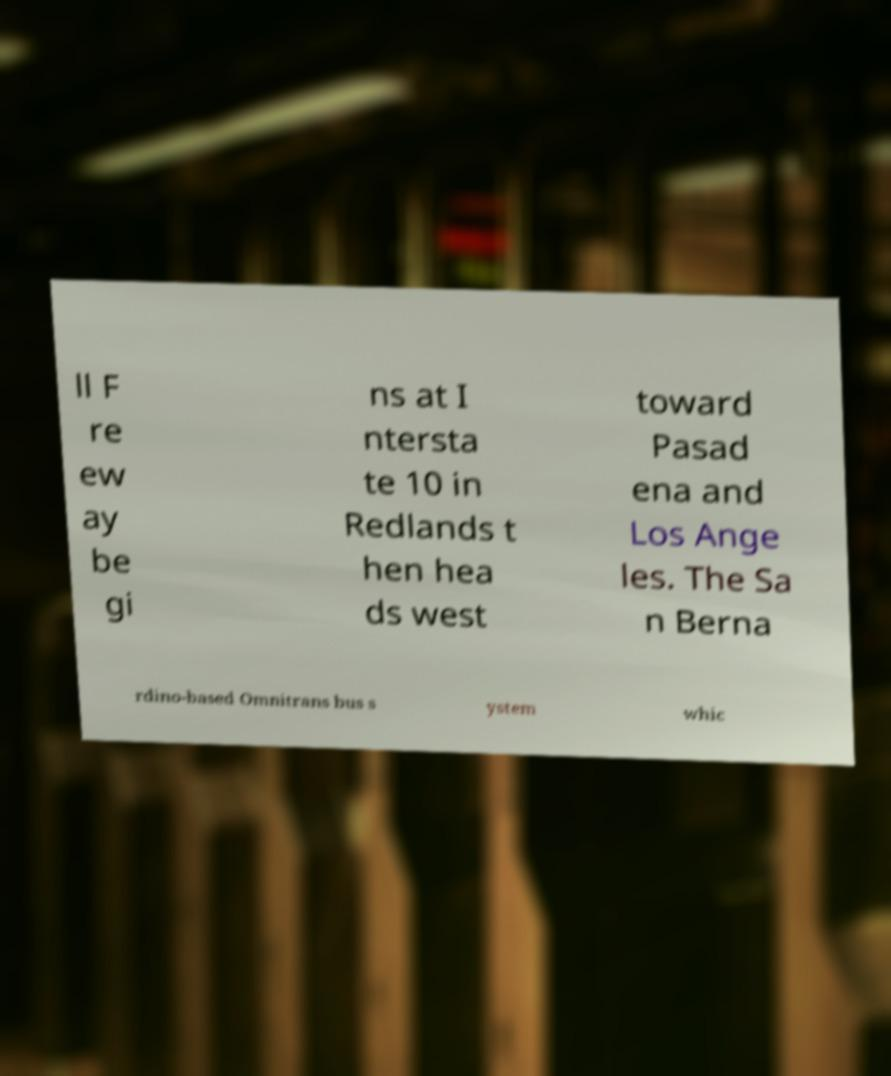Could you extract and type out the text from this image? ll F re ew ay be gi ns at I ntersta te 10 in Redlands t hen hea ds west toward Pasad ena and Los Ange les. The Sa n Berna rdino-based Omnitrans bus s ystem whic 